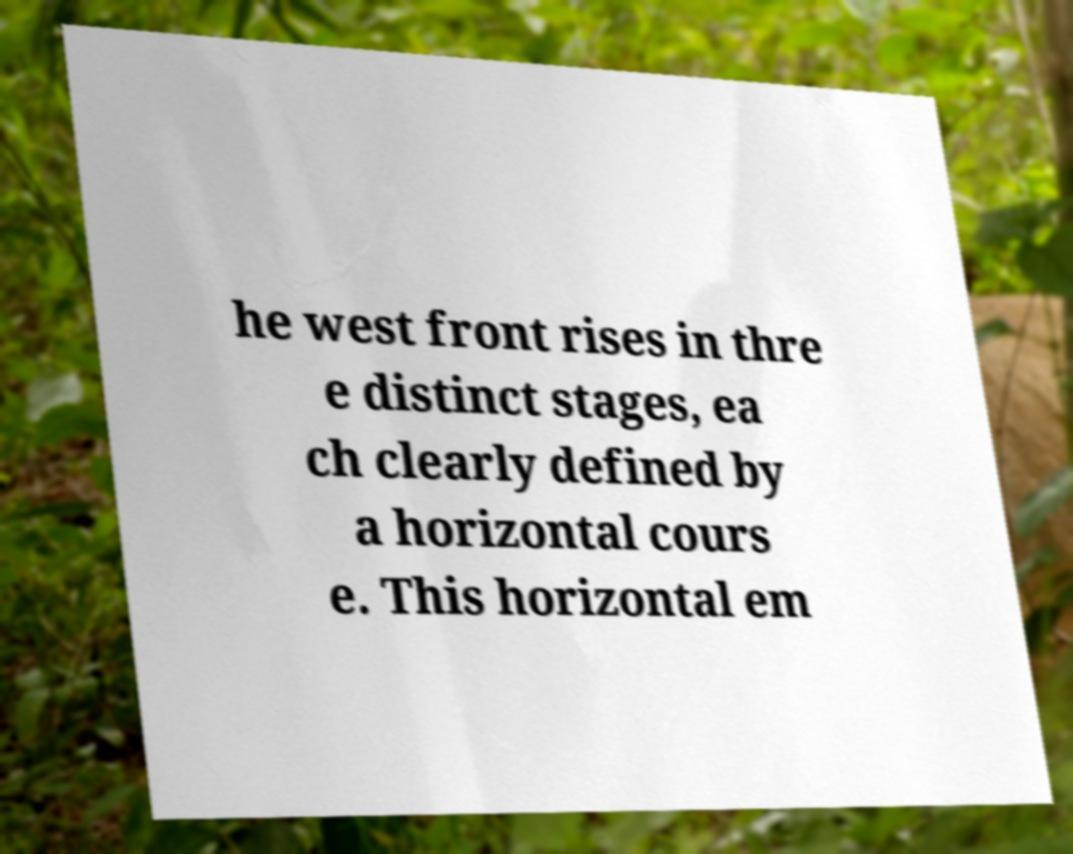Could you extract and type out the text from this image? he west front rises in thre e distinct stages, ea ch clearly defined by a horizontal cours e. This horizontal em 